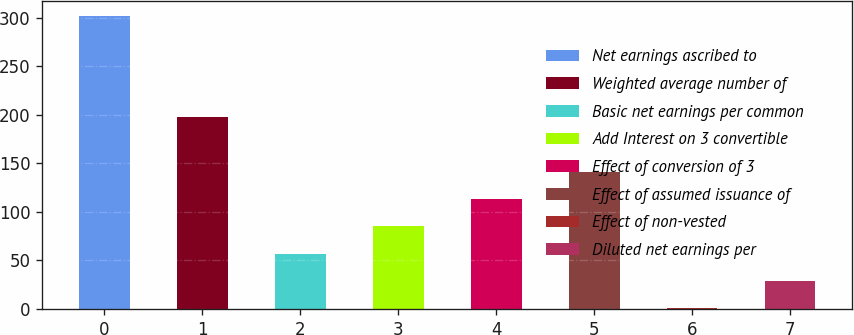Convert chart to OTSL. <chart><loc_0><loc_0><loc_500><loc_500><bar_chart><fcel>Net earnings ascribed to<fcel>Weighted average number of<fcel>Basic net earnings per common<fcel>Add Interest on 3 convertible<fcel>Effect of conversion of 3<fcel>Effect of assumed issuance of<fcel>Effect of non-vested<fcel>Diluted net earnings per<nl><fcel>302.21<fcel>197.57<fcel>57.02<fcel>85.13<fcel>113.24<fcel>141.35<fcel>0.8<fcel>28.91<nl></chart> 